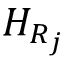Convert formula to latex. <formula><loc_0><loc_0><loc_500><loc_500>H _ { R _ { j } }</formula> 